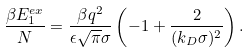<formula> <loc_0><loc_0><loc_500><loc_500>\frac { \beta E _ { 1 } ^ { e x } } { N } = \frac { \beta q ^ { 2 } } { \epsilon \sqrt { \pi } \sigma } \left ( - 1 + \frac { 2 } { ( k _ { D } \sigma ) ^ { 2 } } \right ) .</formula> 